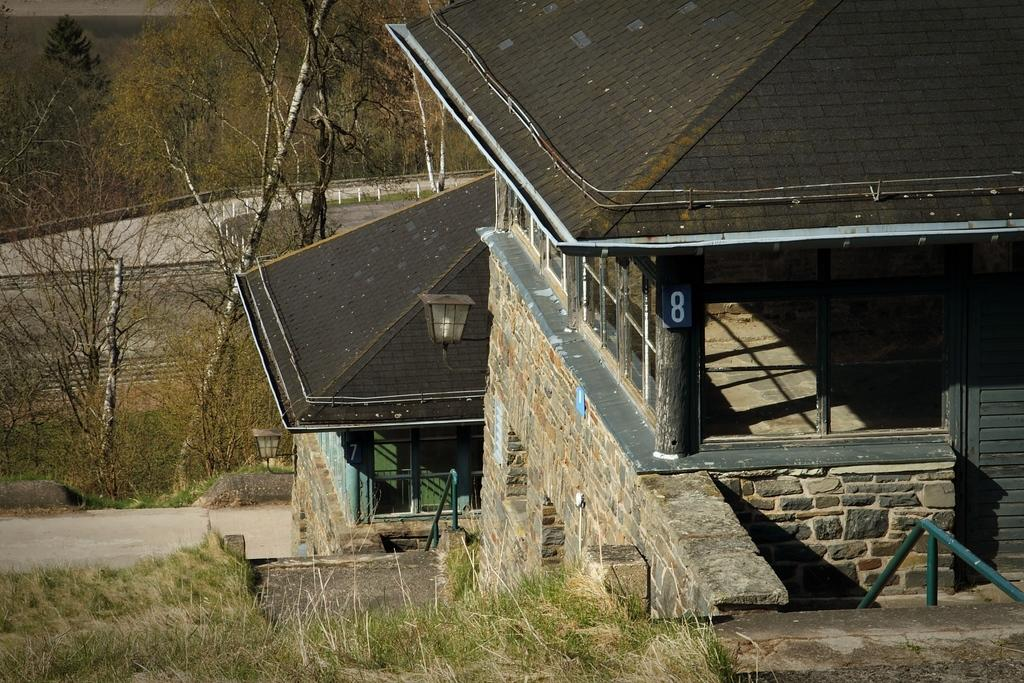What type of structures are located on the right side of the image? There are buildings on the right side of the image. What type of natural elements are on the left side of the image? There are trees and grass on the left side of the image. What type of barrier is present on the left side of the image? There is fencing on the left side of the image. How many lights are visible on the building in the image? There are two lights on the building. Can you see a judge walking on the bridge in the image? There is no bridge, judge, or any walking figure in the image. 